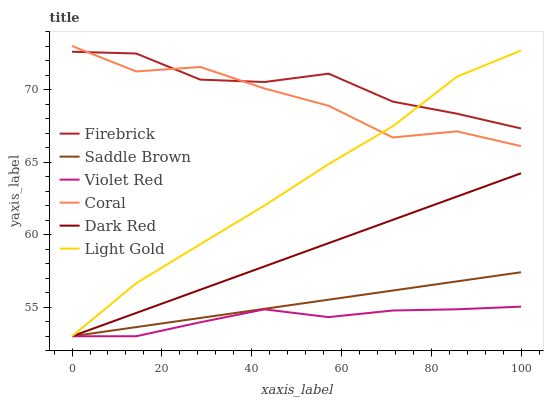Does Violet Red have the minimum area under the curve?
Answer yes or no. Yes. Does Firebrick have the maximum area under the curve?
Answer yes or no. Yes. Does Dark Red have the minimum area under the curve?
Answer yes or no. No. Does Dark Red have the maximum area under the curve?
Answer yes or no. No. Is Dark Red the smoothest?
Answer yes or no. Yes. Is Coral the roughest?
Answer yes or no. Yes. Is Coral the smoothest?
Answer yes or no. No. Is Dark Red the roughest?
Answer yes or no. No. Does Violet Red have the lowest value?
Answer yes or no. Yes. Does Coral have the lowest value?
Answer yes or no. No. Does Coral have the highest value?
Answer yes or no. Yes. Does Dark Red have the highest value?
Answer yes or no. No. Is Dark Red less than Firebrick?
Answer yes or no. Yes. Is Firebrick greater than Violet Red?
Answer yes or no. Yes. Does Light Gold intersect Saddle Brown?
Answer yes or no. Yes. Is Light Gold less than Saddle Brown?
Answer yes or no. No. Is Light Gold greater than Saddle Brown?
Answer yes or no. No. Does Dark Red intersect Firebrick?
Answer yes or no. No. 